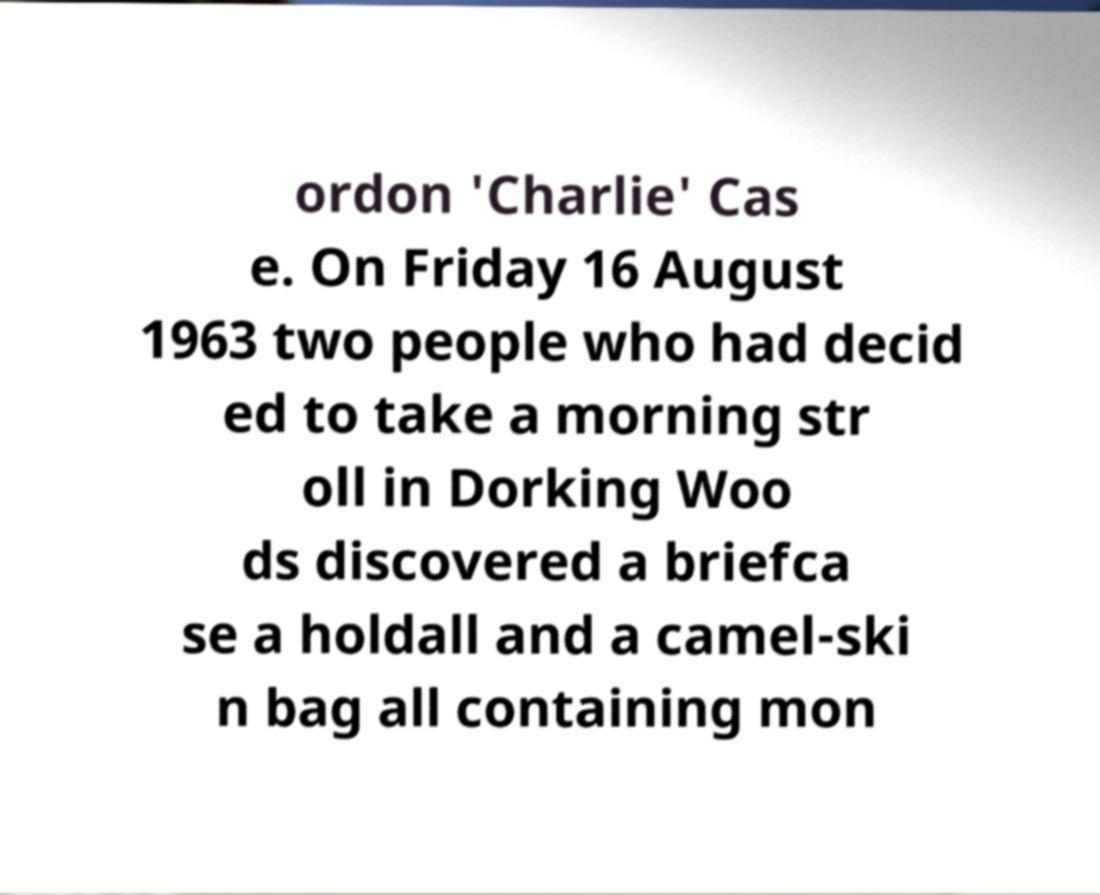There's text embedded in this image that I need extracted. Can you transcribe it verbatim? ordon 'Charlie' Cas e. On Friday 16 August 1963 two people who had decid ed to take a morning str oll in Dorking Woo ds discovered a briefca se a holdall and a camel-ski n bag all containing mon 